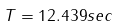Convert formula to latex. <formula><loc_0><loc_0><loc_500><loc_500>T = 1 2 . 4 3 9 s e c</formula> 